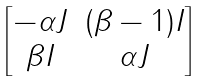Convert formula to latex. <formula><loc_0><loc_0><loc_500><loc_500>\begin{bmatrix} - \alpha J & ( \beta - 1 ) I \\ \beta I & \alpha J \end{bmatrix}</formula> 